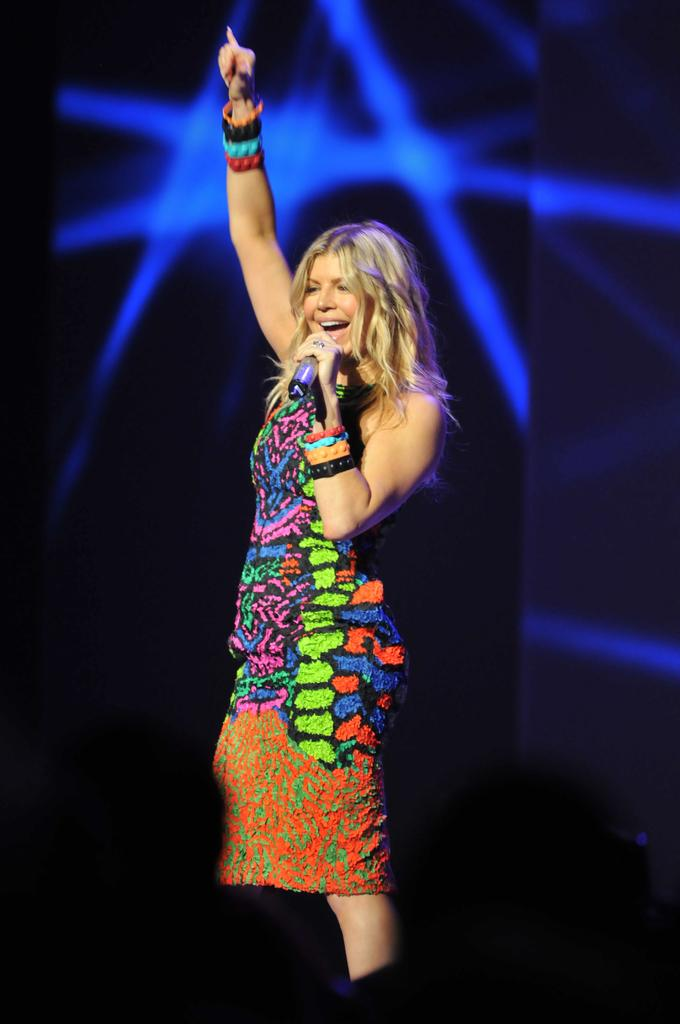Who is the main subject in the image? There is a woman in the image. What is the woman doing in the image? The woman is talking on a microphone. What is the woman's facial expression in the image? The woman is smiling. What can be seen in the background of the image? There is a screen in the background of the image. What type of surface is visible in the image? The image shows a floor. How many houses are visible in the image? There are no houses visible in the image. What color is the woman's hair in the image? The provided facts do not mention the color of the woman's hair, so we cannot determine it from the image. Is there a hen present in the image? There is no hen present in the image. 